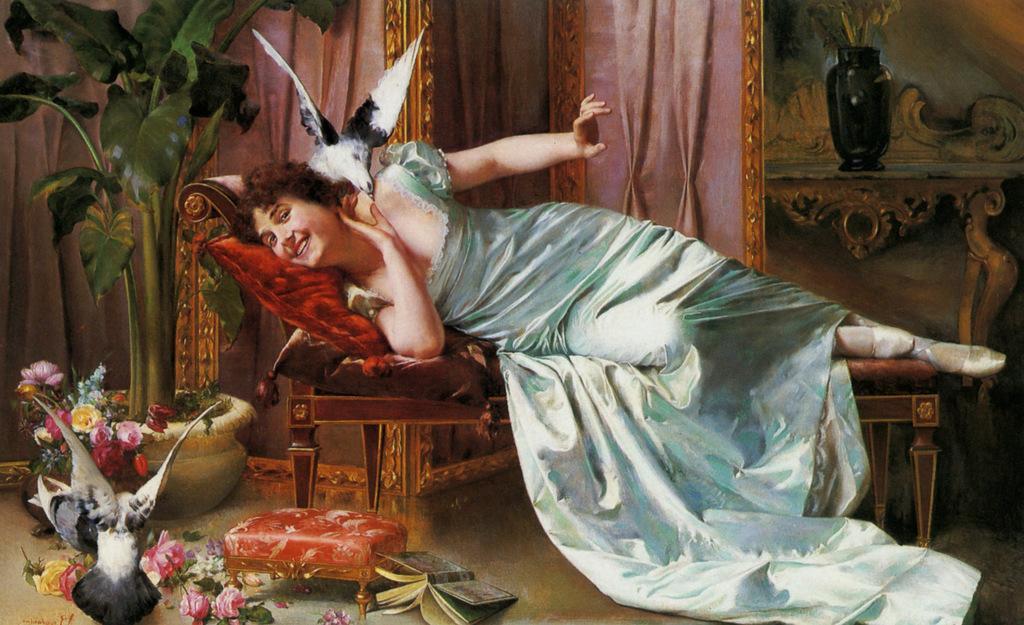Please provide a concise description of this image. In the picture we can see a painting of a woman lying on the bed with a red color pillow and she is smiling and on her neck we can see a bird sitting with a flying position and on the floor, we can see some house plants and flowers to it and behind it we can see a wall with some curtains and some paintings to it. 